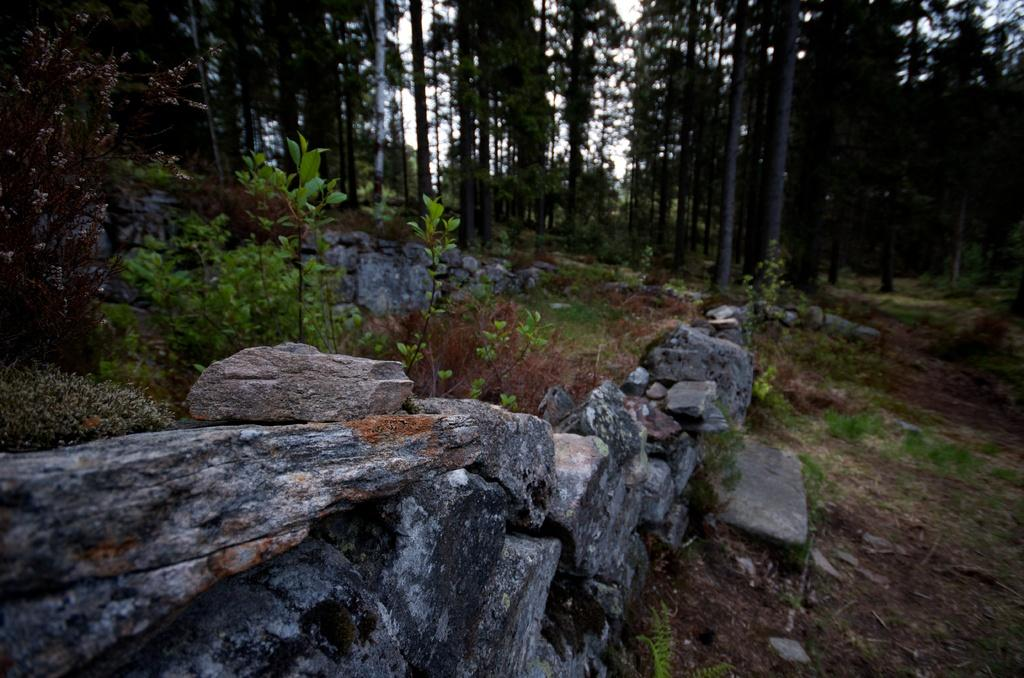What type of natural elements can be seen in the front of the image? There are stones in the front of the image. What can be found on the left side of the image? There are plants on the left side of the image. What type of vegetation is present on the right side of the image? There is grass on the ground on the right side of the image. What is visible in the background of the image? There are trees in the background of the image. What type of weather can be seen in the image? The provided facts do not mention any weather conditions, so it cannot be determined from the image. Is this a cemetery, and if so, where are the gravestones located? There is no mention of a cemetery or gravestones in the provided facts, so it cannot be determined from the image. 